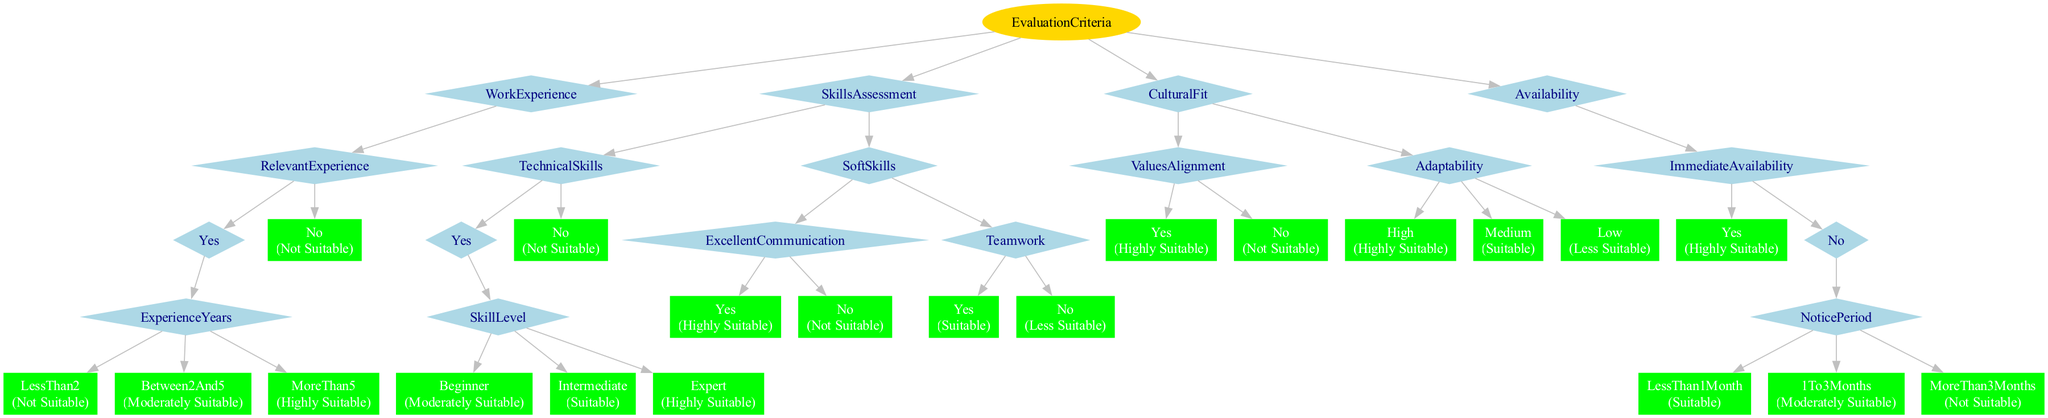What is the output if a candidate has less than 2 years of relevant experience? The decision tree flows down from the "WorkExperience" criterion. If the candidate has "No" relevant experience, the output is "Not Suitable". If the candidate has "Yes" relevant experience and less than 2 years, the output is again "Not Suitable".
Answer: Not Suitable How many criteria are used for evaluating candidates? The diagram outlines four main criteria: Work Experience, Skills Assessment, Cultural Fit, and Availability. Counting these gives us a total of four evaluation criteria.
Answer: 4 What is the suitability outcome if a candidate has excellent communication and teamwork skills? The path starts from "SkillsAssessment", where "ExcellentCommunication" and "Teamwork" both have "Yes" options. "ExcellentCommunication" leads to "Highly Suitable," and "Teamwork" leads to "Suitable." Since both criteria are checked, we can consider the candidate as "Highly Suitable" overall based on excellent communication.
Answer: Highly Suitable What happens if a candidate does not have any technical skills? Following the "SkillsAssessment" branch, if the candidate has "No" for "TechnicalSkills", the output is "Not Suitable". This is a direct connection leading to the conclusion without further evaluations.
Answer: Not Suitable If a candidate's notice period is more than 3 months, what is their suitability? The "Availability" criterion examines "ImmediateAvailability". If "No", it further checks "NoticePeriod". The path indicates that a "MoreThan3Months" notice results in "Not Suitable", making this a clear decision based on the timeline.
Answer: Not Suitable What determines the outcome for a candidate with intermediate technical skills? Examining the "TechnicalSkills" section, if a candidate is labeled as "Intermediate," the corresponding outcome is "Suitable." This flow straightforwardly leads from "TechnicalSkills" to its associated level of suitability.
Answer: Suitable What happens if a candidate has high adaptability but misaligns with company values? In "CulturalFit," if the candidate has "ValuesAlignment" as "No," the outcome is "Not Suitable." Although "High" adaptability may lead to "Highly Suitable" in another path, "No" to "ValuesAlignment" takes precedence for the final outcome.
Answer: Not Suitable What is the suitability for a candidate with 5 years of relevant experience and excellent communication? "RelevantExperience" leads to "Between2And5" years making them "Moderately Suitable." Checking "ExcellentCommunication" results in "Highly Suitable." Thus, combining the two gives us a higher level of suitability overall.
Answer: Highly Suitable 